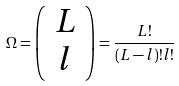<formula> <loc_0><loc_0><loc_500><loc_500>\Omega = \left ( \begin{array} { c } L \\ l \\ \end{array} \right ) = \frac { L ! } { ( L - l ) ! l ! }</formula> 